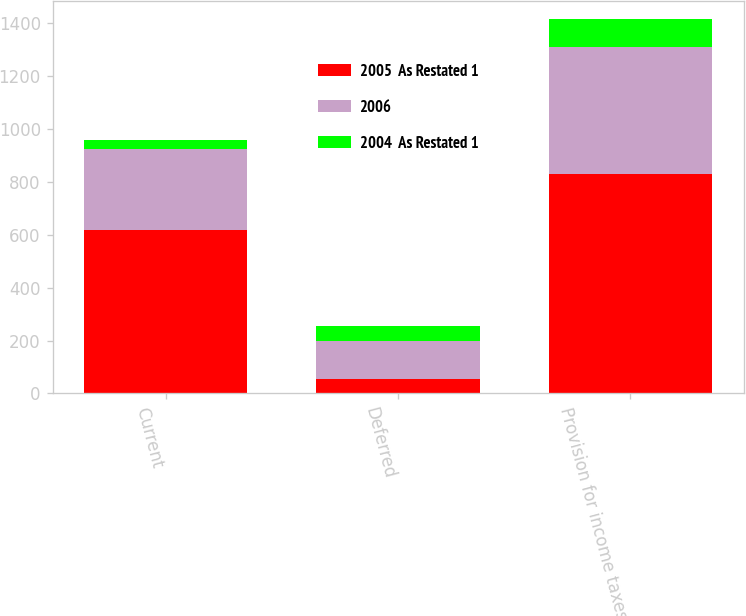Convert chart. <chart><loc_0><loc_0><loc_500><loc_500><stacked_bar_chart><ecel><fcel>Current<fcel>Deferred<fcel>Provision for income taxes<nl><fcel>2005  As Restated 1<fcel>619<fcel>56<fcel>829<nl><fcel>2006<fcel>305<fcel>144<fcel>480<nl><fcel>2004  As Restated 1<fcel>34<fcel>53<fcel>104<nl></chart> 